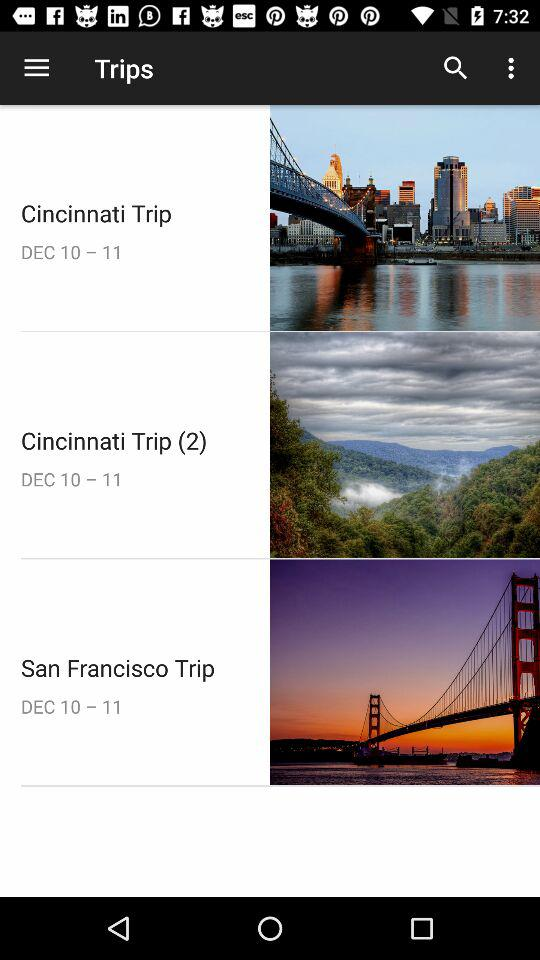What is the date range for the San Francisco trip? The date range for the San Francisco trip is from December 10 to December 11. 